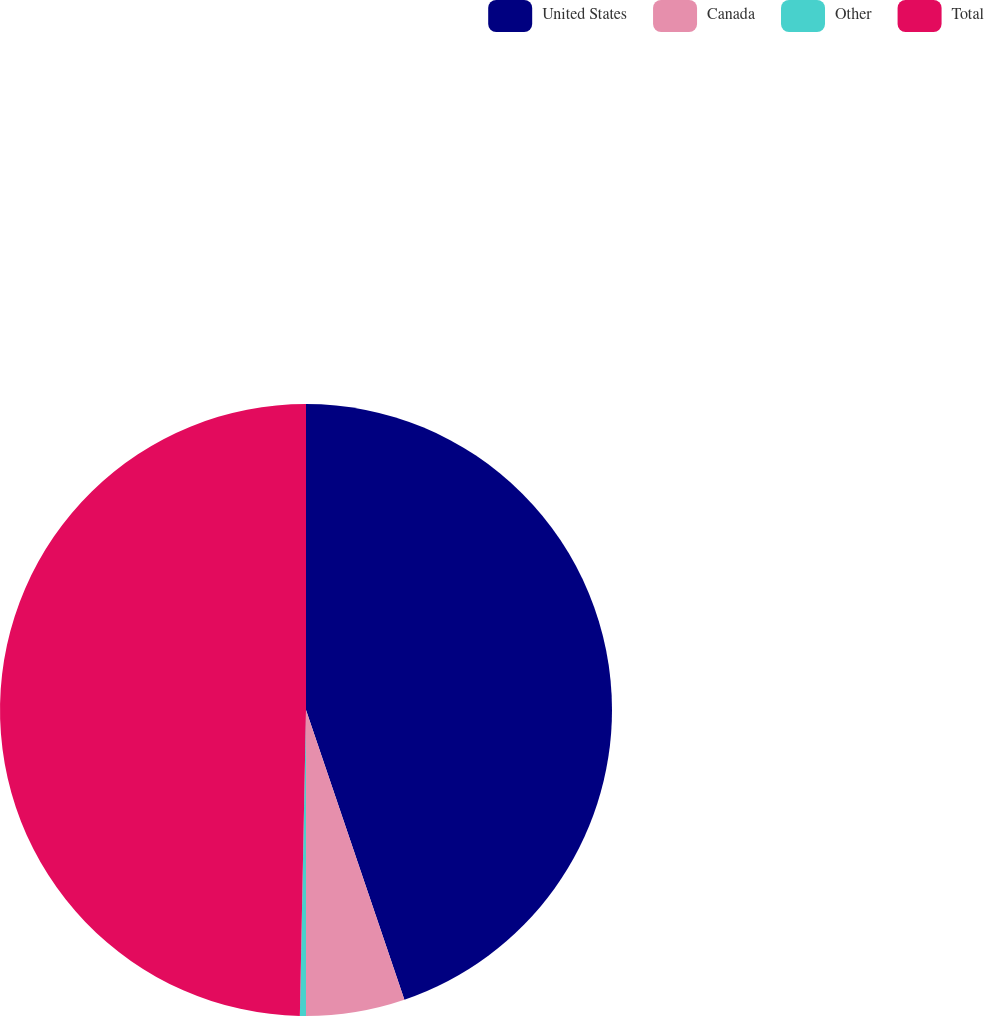<chart> <loc_0><loc_0><loc_500><loc_500><pie_chart><fcel>United States<fcel>Canada<fcel>Other<fcel>Total<nl><fcel>44.79%<fcel>5.21%<fcel>0.32%<fcel>49.68%<nl></chart> 